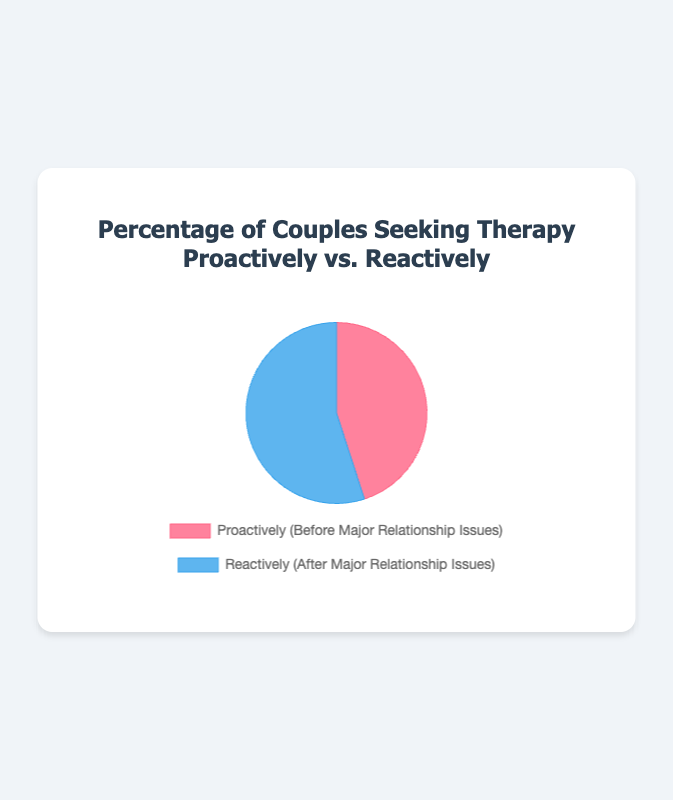How many couples seek therapy proactively and reactively combined? The figure shows that 45% of couples seek therapy proactively and 55% reactively. Adding these percentages gives us the total percentage of couples seeking therapy. 45 + 55 = 100
Answer: 100 Which category has more couples seeking therapy, proactively or reactively? The figure shows that 45% of couples seek therapy proactively and 55% seek therapy reactively. Comparing these two percentages, 55% is greater than 45%.
Answer: Reactively What is the ratio of couples seeking therapy reactively to those seeking it proactively? From the figure, the percentage of couples seeking therapy reactively is 55% and proactively is 45%. The ratio is calculated as 55/45, which simplifies to 11/9.
Answer: 11:9 If 100 couples are surveyed, how many would be seeking therapy proactively? The figure shows that 45% of couples seek therapy proactively. If 100 couples are surveyed, the number seeking therapy proactively is 45% of 100. This is calculated as (45/100) * 100 = 45.
Answer: 45 By how much percentage do more couples seek therapy reactively than proactively? The figure indicates that 55% of couples seek therapy reactively and 45% proactively. The difference is 55% - 45% = 10%.
Answer: 10% What is the combined percentage of couples seeking therapy whether proactively or reactively? The figure shows 45% of couples seek therapy proactively and 55% reactively. Adding these percentages together gives 45 + 55 = 100%.
Answer: 100% What percentage of couples are not seeking therapy either proactively or reactively? The figure presents the total percentage of couples seeking therapy as 45% proactively and 55% reactively, which sums to 100%. Thus, 0% of couples are not seeking therapy.
Answer: 0% Which section of the pie chart is larger, the one representing couples seeking therapy proactively or reactively? The figure shows 45% of couples seek therapy proactively and 55% reactively. Since 55% is larger than 45%, the section representing reactive therapy seekers is larger.
Answer: Reactively 